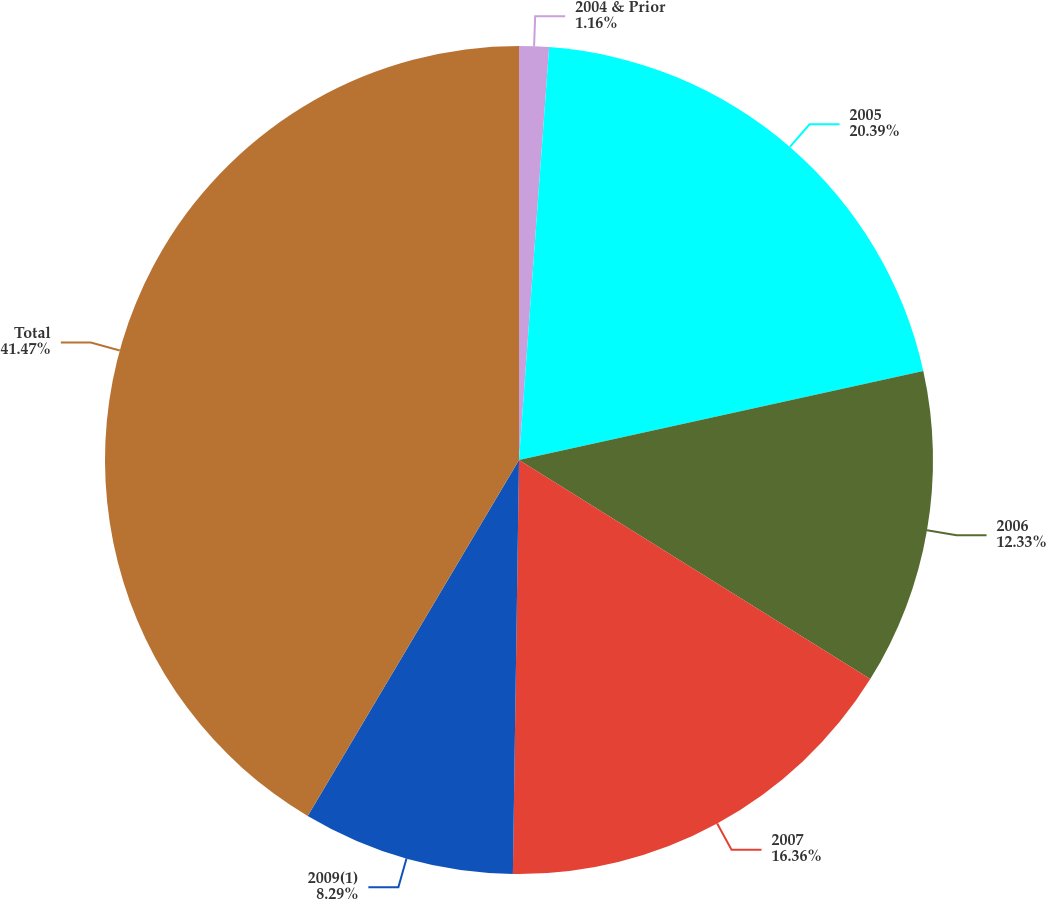Convert chart. <chart><loc_0><loc_0><loc_500><loc_500><pie_chart><fcel>2004 & Prior<fcel>2005<fcel>2006<fcel>2007<fcel>2009(1)<fcel>Total<nl><fcel>1.16%<fcel>20.39%<fcel>12.33%<fcel>16.36%<fcel>8.29%<fcel>41.48%<nl></chart> 